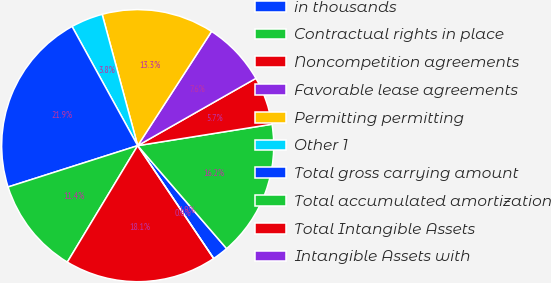Convert chart. <chart><loc_0><loc_0><loc_500><loc_500><pie_chart><fcel>in thousands<fcel>Contractual rights in place<fcel>Noncompetition agreements<fcel>Favorable lease agreements<fcel>Permitting permitting<fcel>Other 1<fcel>Total gross carrying amount<fcel>Total accumulated amortization<fcel>Total Intangible Assets<fcel>Intangible Assets with<nl><fcel>1.91%<fcel>16.18%<fcel>5.72%<fcel>7.63%<fcel>13.34%<fcel>3.81%<fcel>21.9%<fcel>11.44%<fcel>18.08%<fcel>0.0%<nl></chart> 